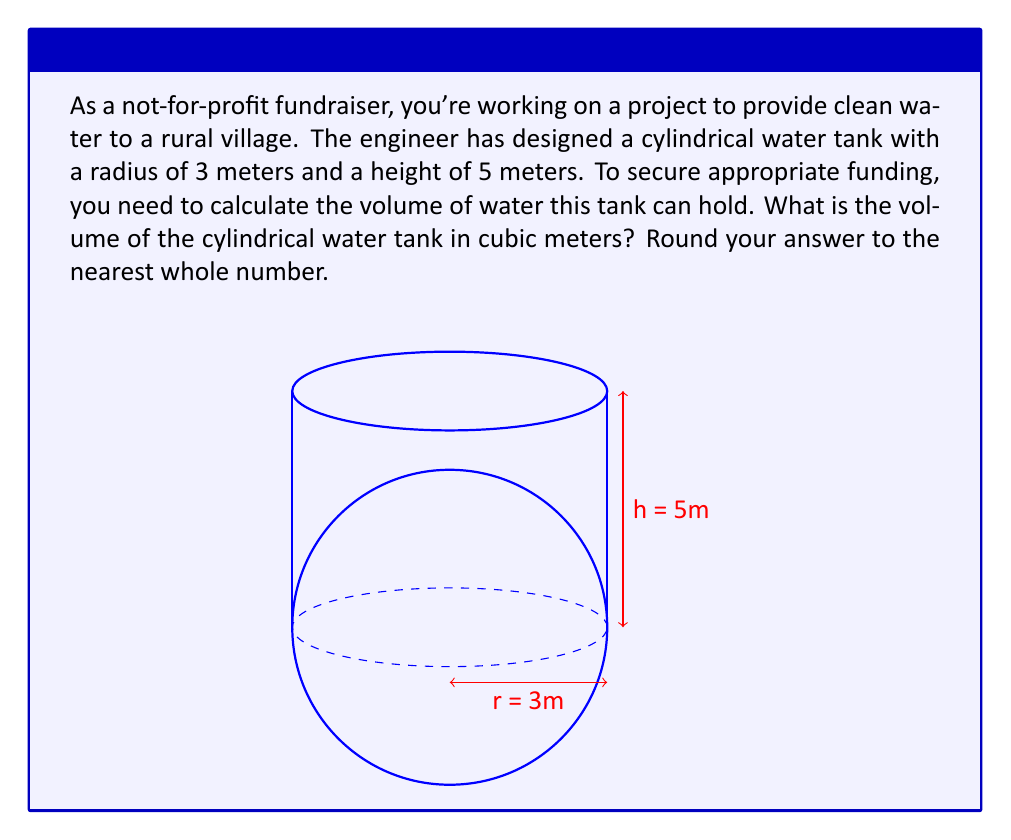Give your solution to this math problem. To solve this problem, we need to use the formula for the volume of a cylinder:

$$V = \pi r^2 h$$

Where:
$V$ = volume
$r$ = radius of the base
$h$ = height of the cylinder

Given:
$r = 3$ meters
$h = 5$ meters

Let's substitute these values into our formula:

$$V = \pi (3 \text{ m})^2 (5 \text{ m})$$

Now, let's calculate step by step:

1) First, calculate $r^2$:
   $3^2 = 9$

2) Multiply by $\pi$:
   $9\pi \approx 28.27$

3) Multiply by the height:
   $28.27 \times 5 = 141.37$

Therefore, the volume of the water tank is approximately 141.37 cubic meters.

Rounding to the nearest whole number as requested, we get 141 cubic meters.

This calculation is crucial for your fundraising efforts as it helps quantify the impact of the project. A 141 cubic meter tank can hold 141,000 liters of water, which can serve a significant number of people in the village, demonstrating the tangible social impact of the project to potential donors.
Answer: 141 cubic meters 